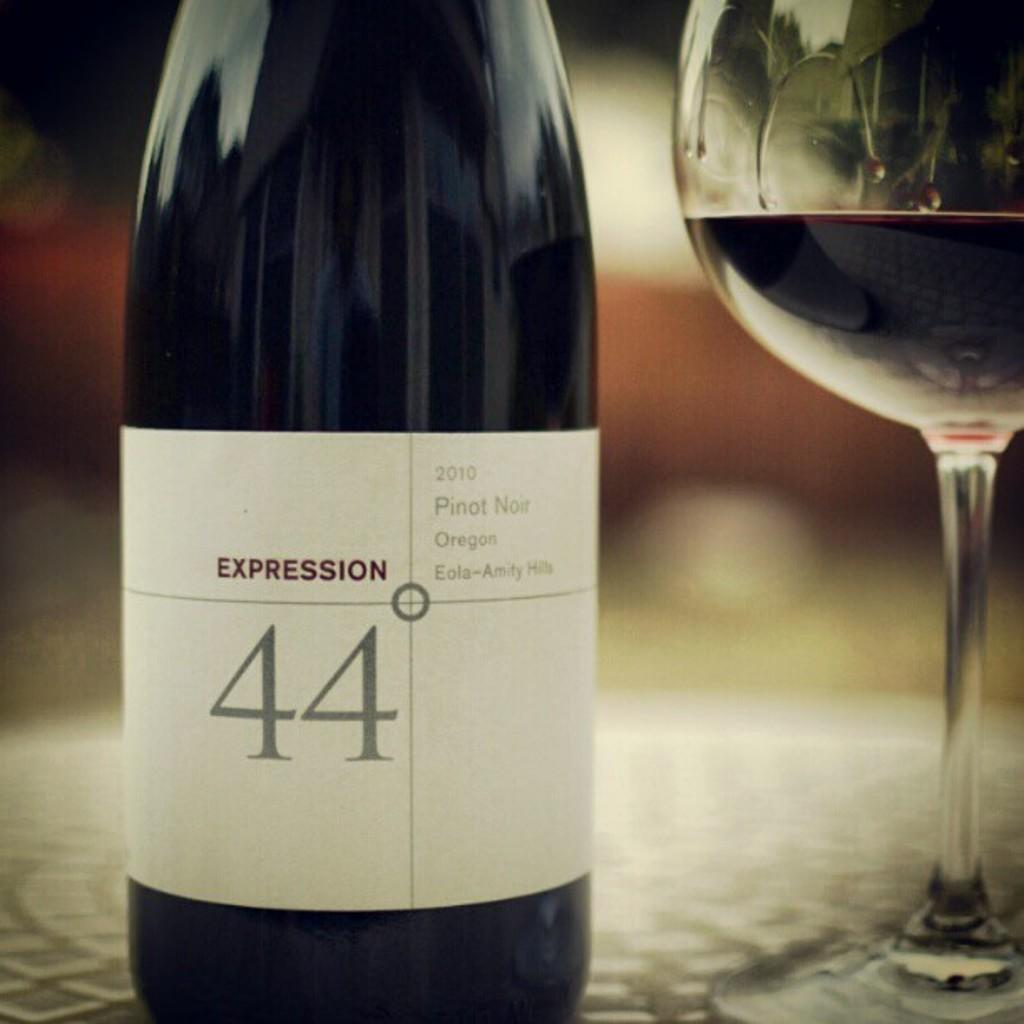<image>
Relay a brief, clear account of the picture shown. A bottle of wine has the brand name expression and the number 44 on the label. 